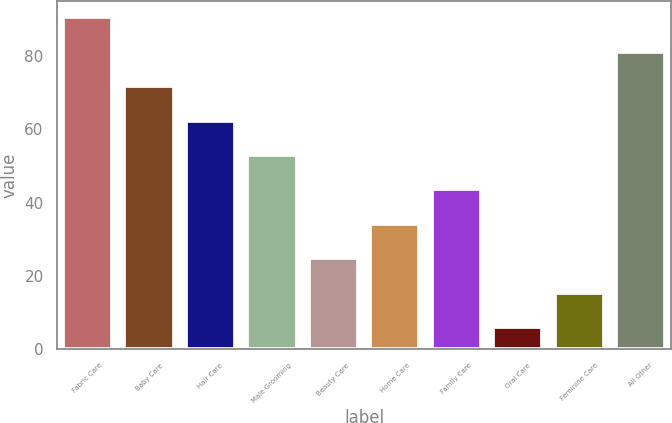Convert chart to OTSL. <chart><loc_0><loc_0><loc_500><loc_500><bar_chart><fcel>Fabric Care<fcel>Baby Care<fcel>Hair Care<fcel>Male Grooming<fcel>Beauty Care<fcel>Home Care<fcel>Family Care<fcel>Oral Care<fcel>Feminine Care<fcel>All Other<nl><fcel>90.6<fcel>71.8<fcel>62.4<fcel>53<fcel>24.8<fcel>34.2<fcel>43.6<fcel>6<fcel>15.4<fcel>81.2<nl></chart> 